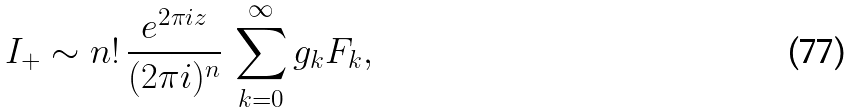<formula> <loc_0><loc_0><loc_500><loc_500>I _ { + } \sim n ! \, \frac { e ^ { 2 \pi i z } } { ( 2 \pi i ) ^ { n } } \, \sum _ { k = 0 } ^ { \infty } g _ { k } F _ { k } ,</formula> 